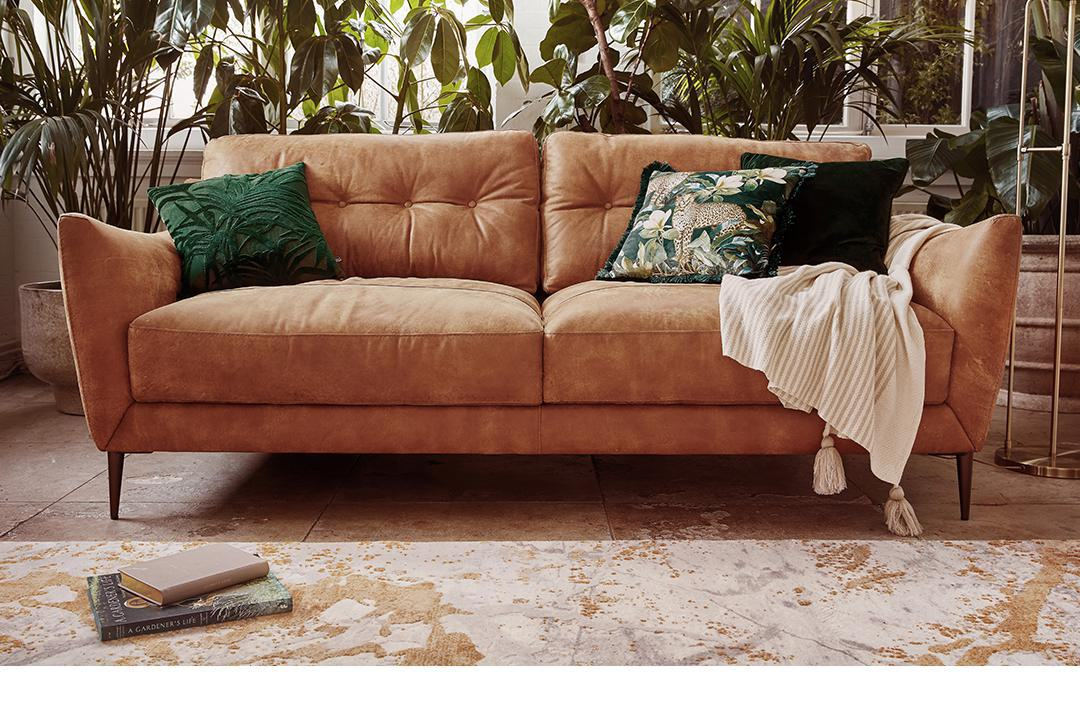Is there a sofa in the image? Yes 